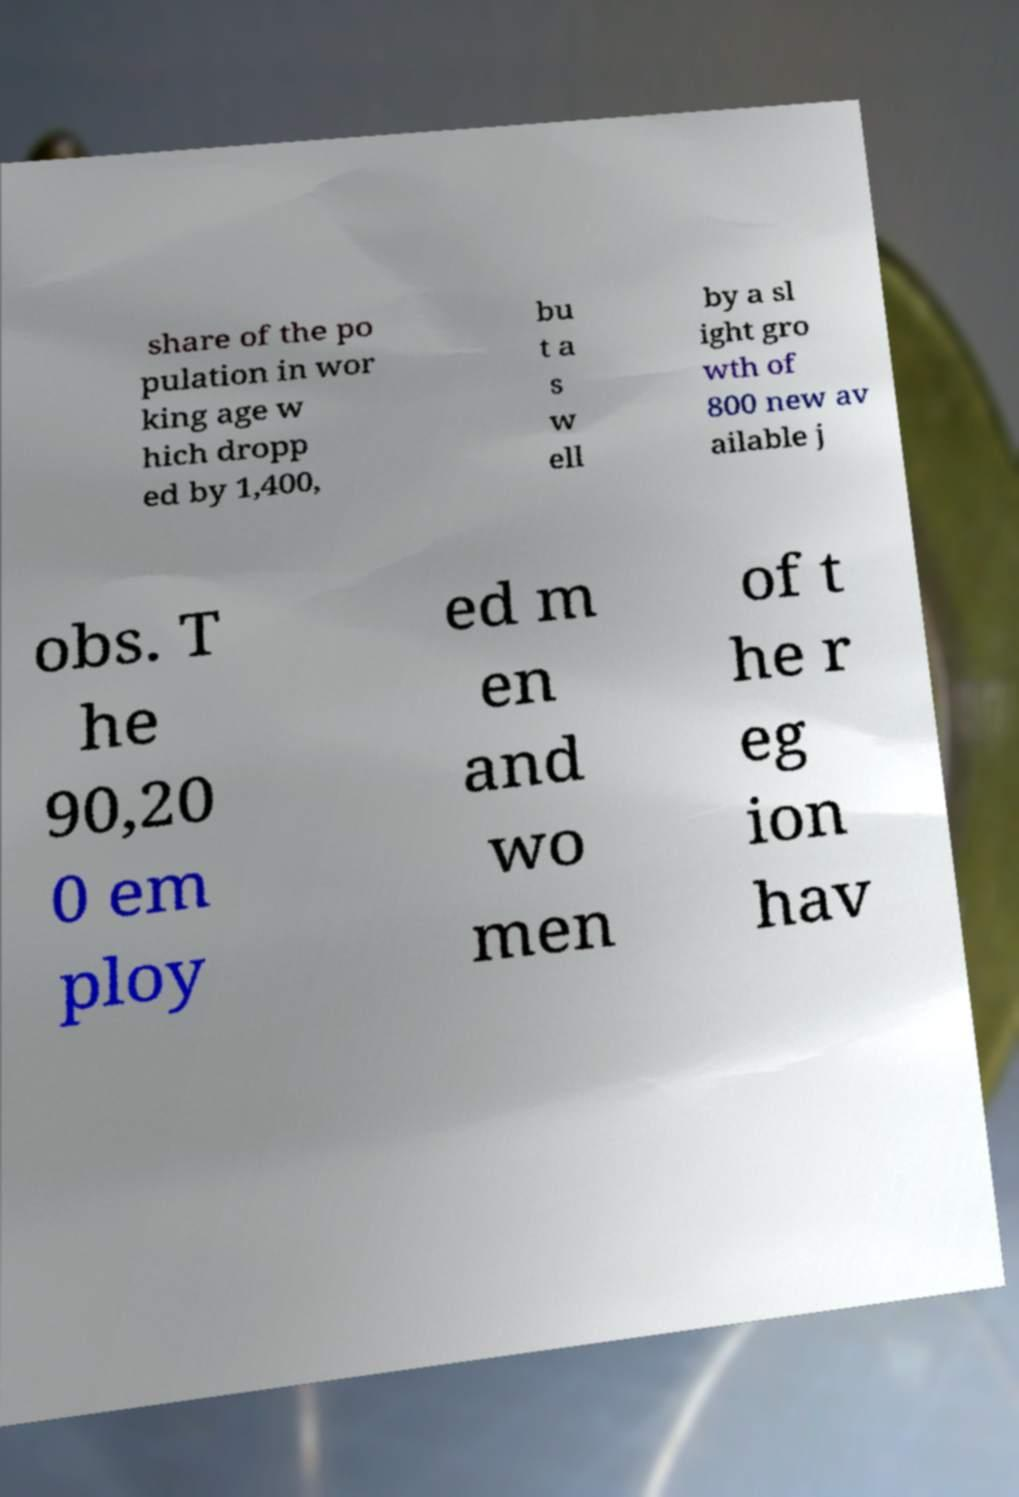Please identify and transcribe the text found in this image. share of the po pulation in wor king age w hich dropp ed by 1,400, bu t a s w ell by a sl ight gro wth of 800 new av ailable j obs. T he 90,20 0 em ploy ed m en and wo men of t he r eg ion hav 